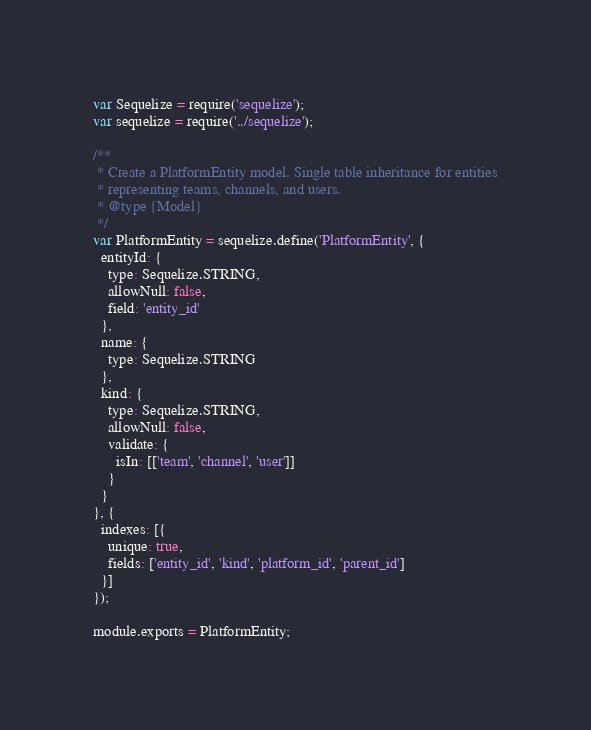<code> <loc_0><loc_0><loc_500><loc_500><_JavaScript_>var Sequelize = require('sequelize');
var sequelize = require('../sequelize');

/**
 * Create a PlatformEntity model. Single table inheritance for entities
 * representing teams, channels, and users.
 * @type {Model}
 */
var PlatformEntity = sequelize.define('PlatformEntity', {
  entityId: {
    type: Sequelize.STRING,
    allowNull: false,
    field: 'entity_id'
  },
  name: {
    type: Sequelize.STRING
  },
  kind: {
    type: Sequelize.STRING,
    allowNull: false,
    validate: {
      isIn: [['team', 'channel', 'user']]
    }
  }
}, {
  indexes: [{
    unique: true,
    fields: ['entity_id', 'kind', 'platform_id', 'parent_id']
  }]
});

module.exports = PlatformEntity;
</code> 